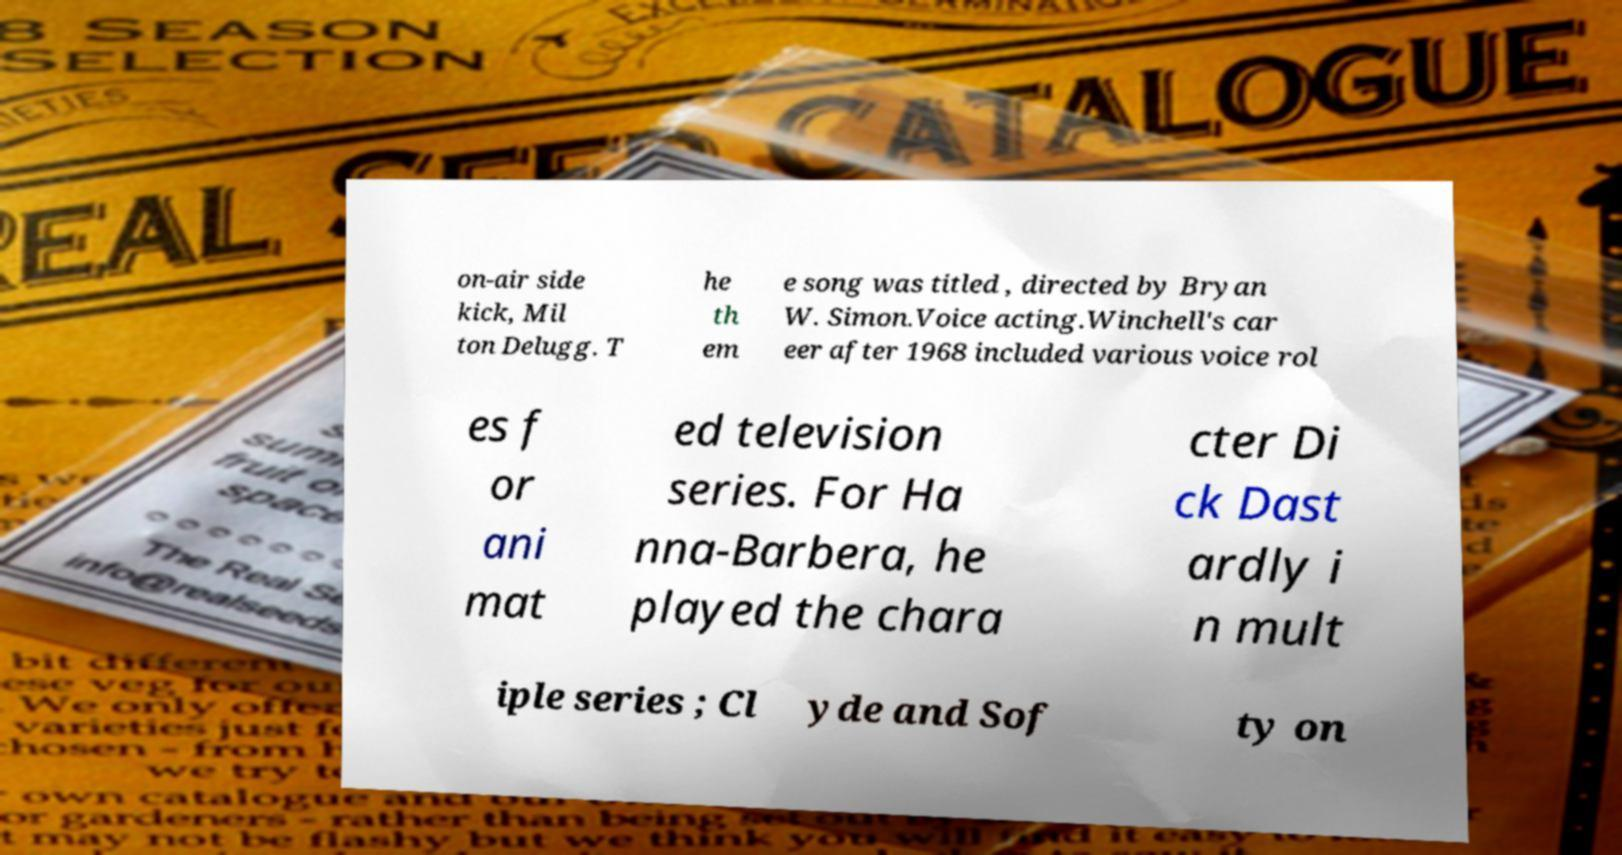What messages or text are displayed in this image? I need them in a readable, typed format. on-air side kick, Mil ton Delugg. T he th em e song was titled , directed by Bryan W. Simon.Voice acting.Winchell's car eer after 1968 included various voice rol es f or ani mat ed television series. For Ha nna-Barbera, he played the chara cter Di ck Dast ardly i n mult iple series ; Cl yde and Sof ty on 